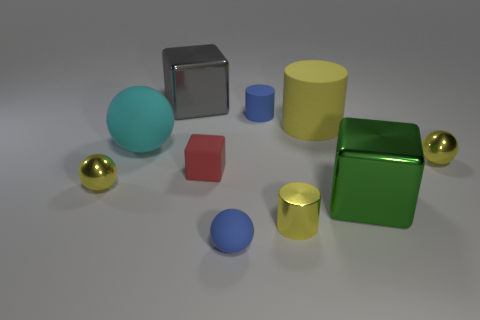Is the number of gray cubes greater than the number of large red matte things?
Your answer should be compact. Yes. Does the metal cylinder have the same color as the big cylinder that is on the right side of the red matte cube?
Offer a terse response. Yes. There is a cylinder that is on the left side of the big yellow object and on the right side of the small blue matte cylinder; what color is it?
Your response must be concise. Yellow. What number of other objects are the same material as the large gray cube?
Your answer should be compact. 4. Are there fewer cubes than metal blocks?
Offer a very short reply. No. Are the large green thing and the small blue object on the right side of the blue sphere made of the same material?
Ensure brevity in your answer.  No. What shape is the yellow metal thing to the left of the tiny cube?
Your answer should be very brief. Sphere. Is there any other thing that is the same color as the tiny matte cylinder?
Your answer should be very brief. Yes. Are there fewer small blue rubber balls behind the cyan matte sphere than metal objects?
Provide a succinct answer. Yes. How many matte things have the same size as the gray shiny block?
Provide a short and direct response. 2. 